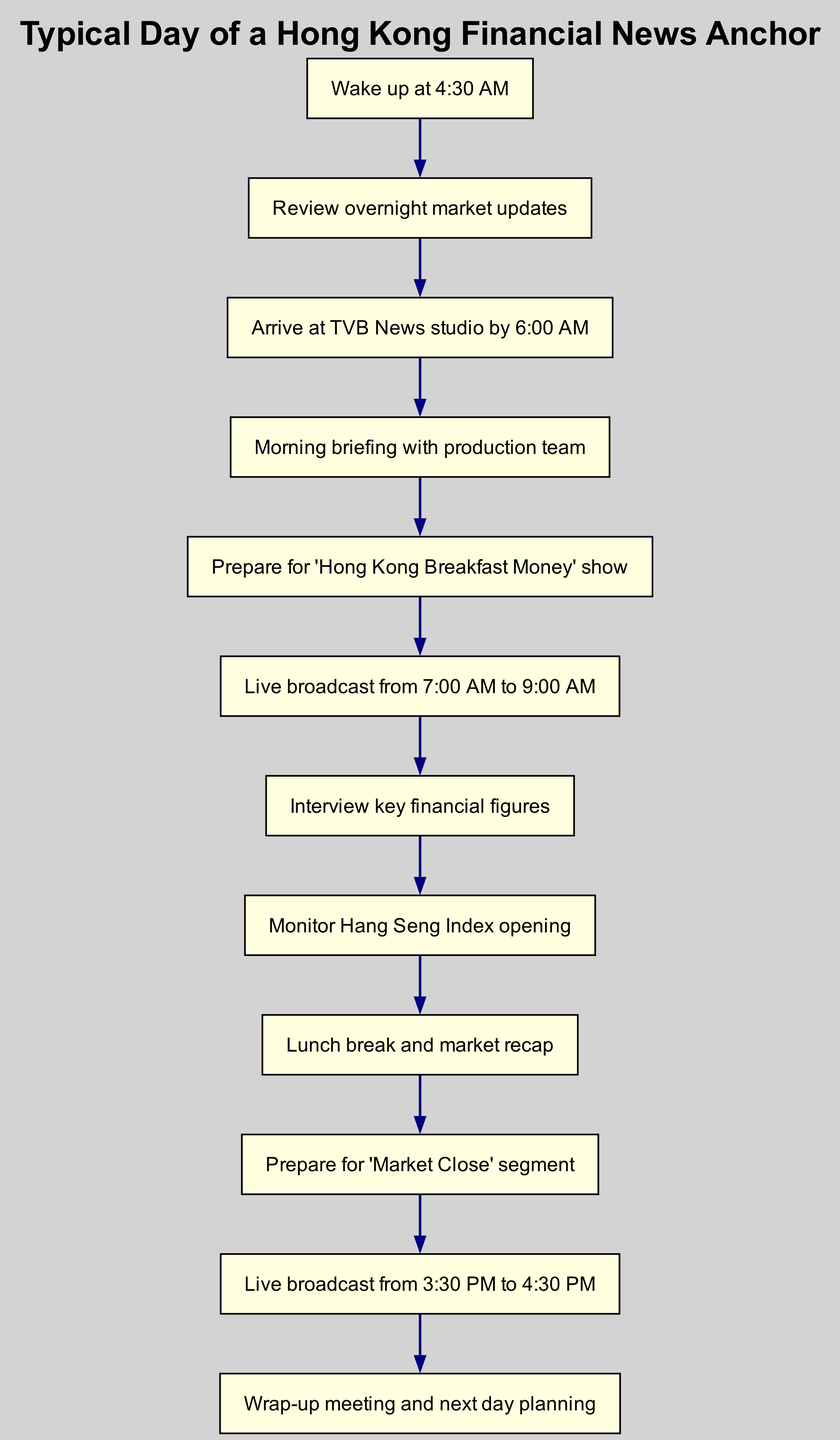What time does the financial news anchor wake up? The diagram states that the first step in the workflow is "Wake up at 4:30 AM", indicating that this is the time the anchor starts their day.
Answer: 4:30 AM How many live broadcasts are there in a typical day? According to the diagram, the anchor has two live broadcasts listed: one from 7:00 AM to 9:00 AM and another from 3:30 PM to 4:30 PM. This means there are two instances where the anchor goes live.
Answer: 2 What is the last task in the workflow? The final task shown in the diagram is "Wrap-up meeting and next day planning", which indicates the end of the anchor's typical day.
Answer: Wrap-up meeting and next day planning What does the anchor prepare for after lunch? Following the "Lunch break and market recap," the next task is "Prepare for 'Market Close' segment", which shows what the anchor prepares for.
Answer: Prepare for 'Market Close' segment What is the time gap between the morning and afternoon broadcasts? The difference between the morning broadcast ending at 9:00 AM and the afternoon broadcast starting at 3:30 PM calculates to 6.5 hours (from 9 AM to 3:30 PM).
Answer: 6.5 hours What task follows the interview with key financial figures? After "Interview key financial figures", the diagram shows the next step is "Monitor Hang Seng Index opening", indicating the sequence of tasks.
Answer: Monitor Hang Seng Index opening What meeting occurs at the end of the day? The last task in the workflow is "Wrap-up meeting and next day planning", denoting the conclusion of the financial news anchor's day.
Answer: Wrap-up meeting and next day planning How does the workflow cycle? The workflow diagram indicates that after the last task ("Wrap-up meeting and next day planning"), it goes back to the first task ("Wake up at 4:30 AM"), showing a continuous cycle.
Answer: Continuous cycle 